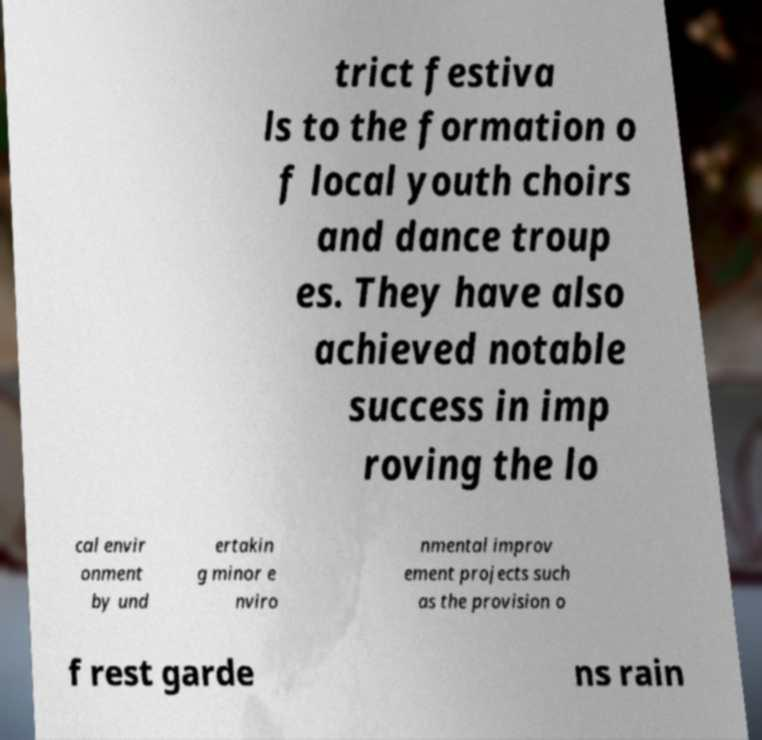For documentation purposes, I need the text within this image transcribed. Could you provide that? trict festiva ls to the formation o f local youth choirs and dance troup es. They have also achieved notable success in imp roving the lo cal envir onment by und ertakin g minor e nviro nmental improv ement projects such as the provision o f rest garde ns rain 